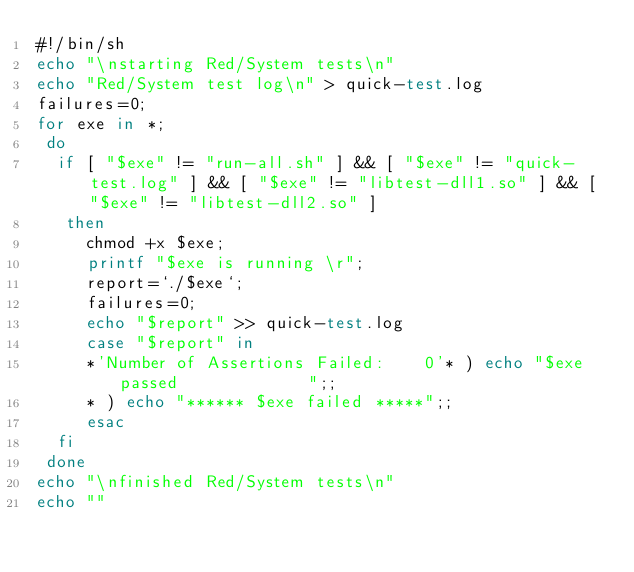<code> <loc_0><loc_0><loc_500><loc_500><_Bash_>#!/bin/sh
echo "\nstarting Red/System tests\n"
echo "Red/System test log\n" > quick-test.log
failures=0;
for exe in *;
 do
  if [ "$exe" != "run-all.sh" ] && [ "$exe" != "quick-test.log" ] && [ "$exe" != "libtest-dll1.so" ] && [ "$exe" != "libtest-dll2.so" ]
   then
     chmod +x $exe;
     printf "$exe is running \r";
     report=`./$exe`;
     failures=0;
     echo "$report" >> quick-test.log
     case "$report" in 
     *'Number of Assertions Failed:    0'* ) echo "$exe passed             ";;
     * ) echo "****** $exe failed *****";;
     esac
  fi   
 done
echo "\nfinished Red/System tests\n"
echo ""
</code> 